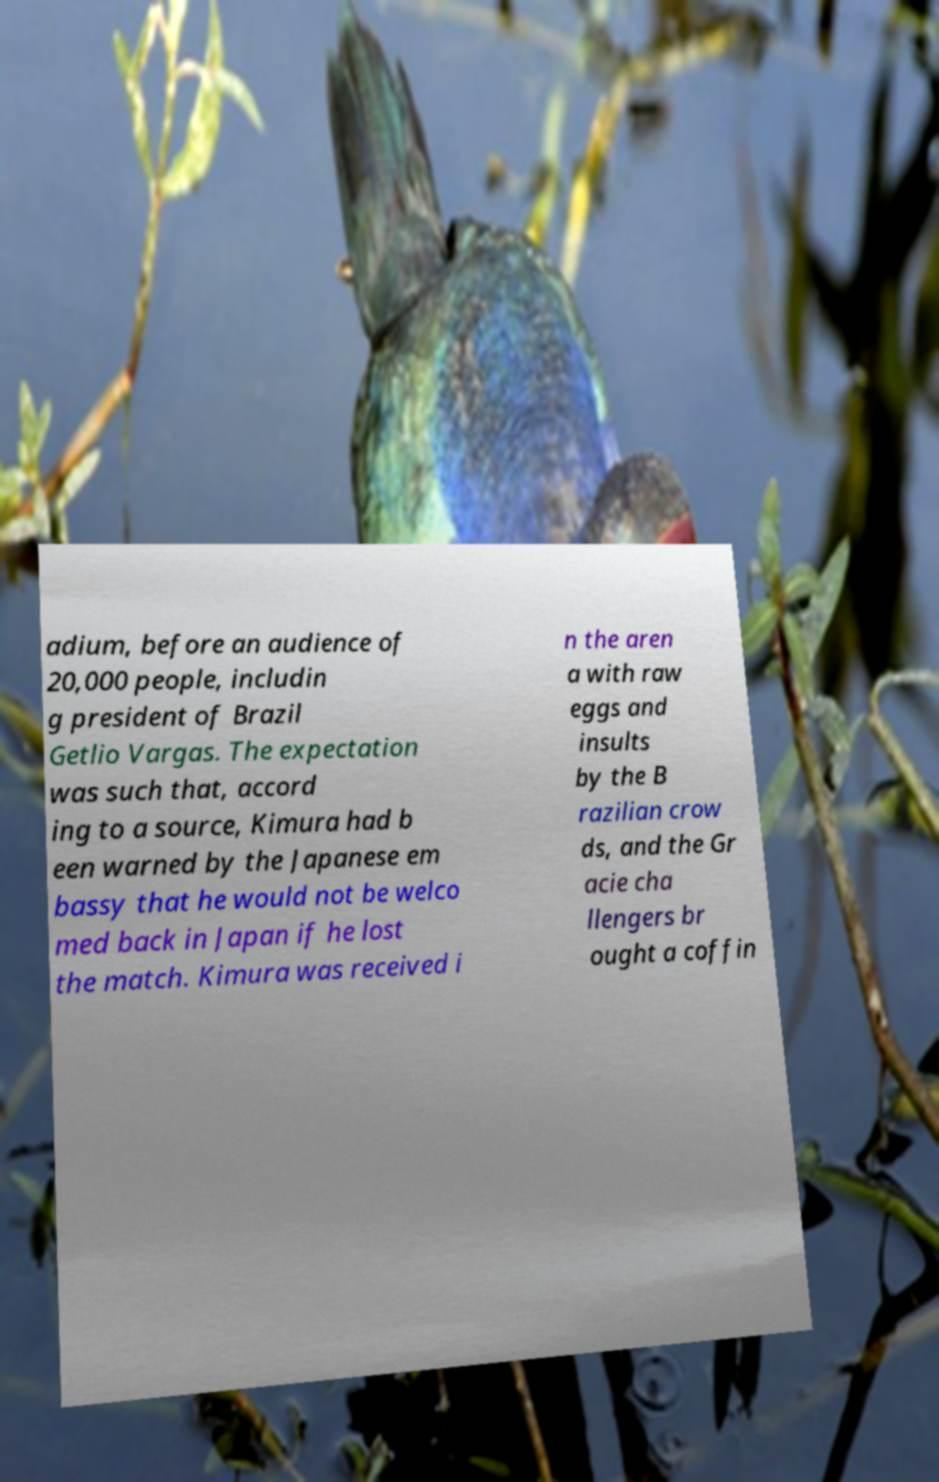I need the written content from this picture converted into text. Can you do that? adium, before an audience of 20,000 people, includin g president of Brazil Getlio Vargas. The expectation was such that, accord ing to a source, Kimura had b een warned by the Japanese em bassy that he would not be welco med back in Japan if he lost the match. Kimura was received i n the aren a with raw eggs and insults by the B razilian crow ds, and the Gr acie cha llengers br ought a coffin 